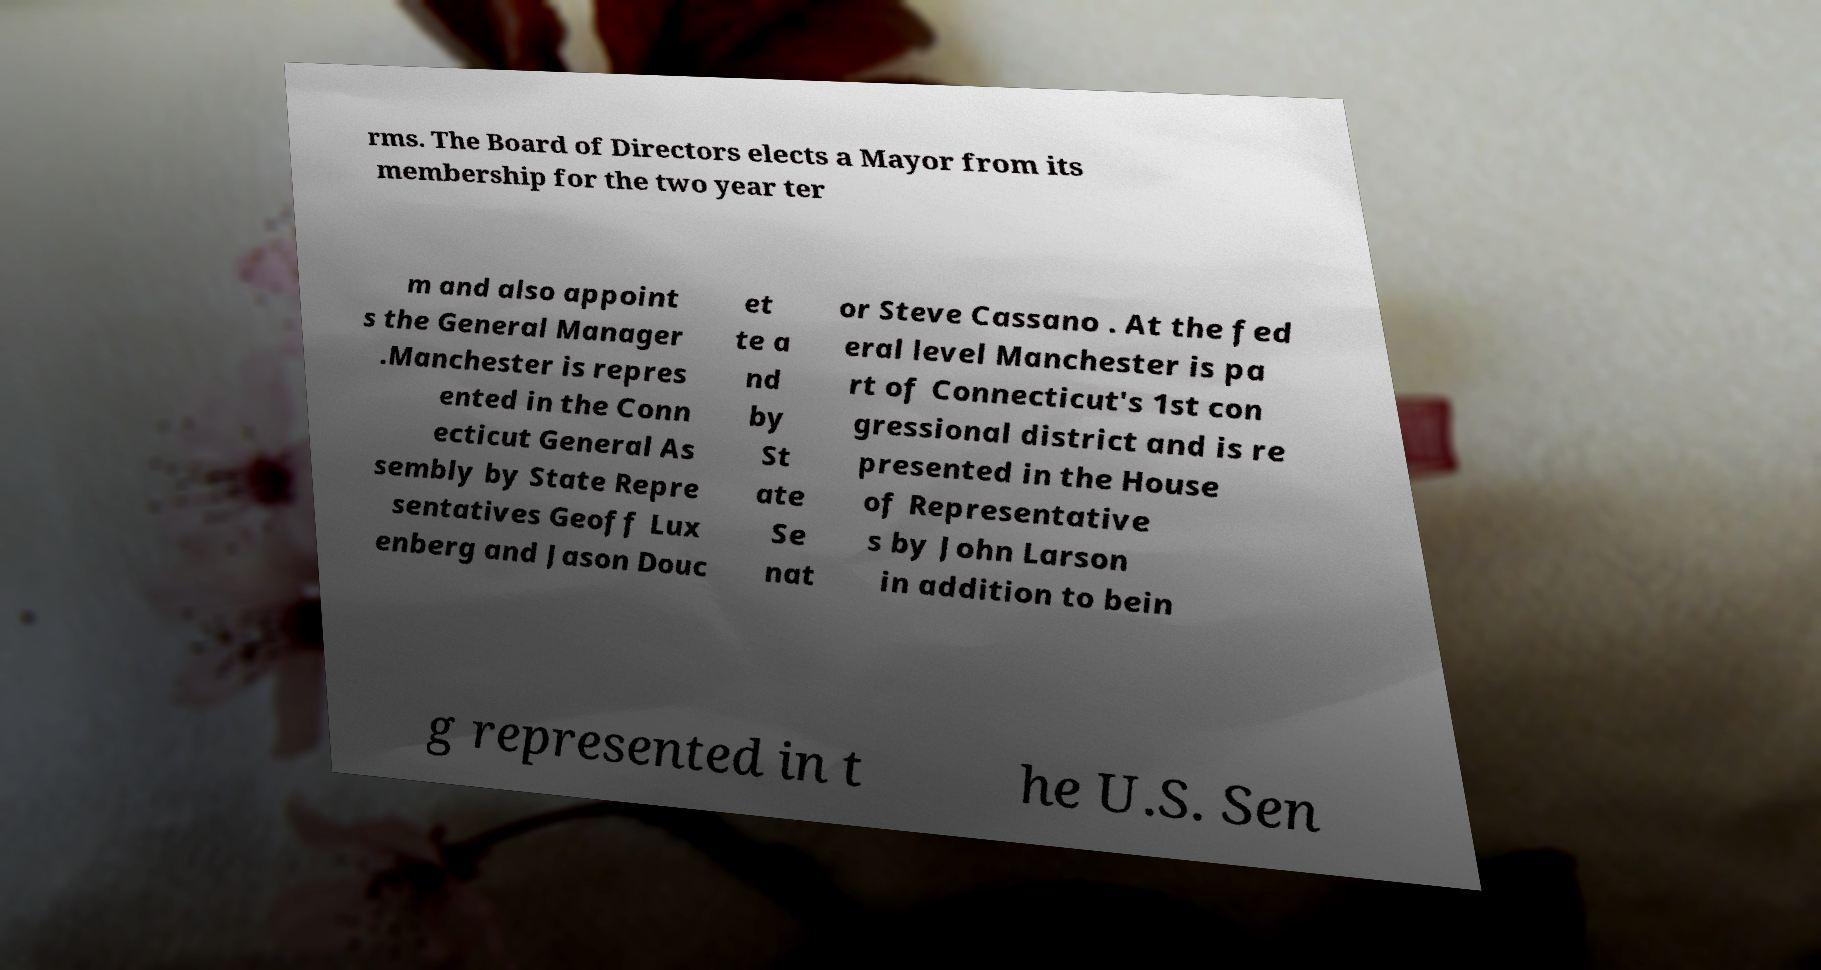I need the written content from this picture converted into text. Can you do that? rms. The Board of Directors elects a Mayor from its membership for the two year ter m and also appoint s the General Manager .Manchester is repres ented in the Conn ecticut General As sembly by State Repre sentatives Geoff Lux enberg and Jason Douc et te a nd by St ate Se nat or Steve Cassano . At the fed eral level Manchester is pa rt of Connecticut's 1st con gressional district and is re presented in the House of Representative s by John Larson in addition to bein g represented in t he U.S. Sen 